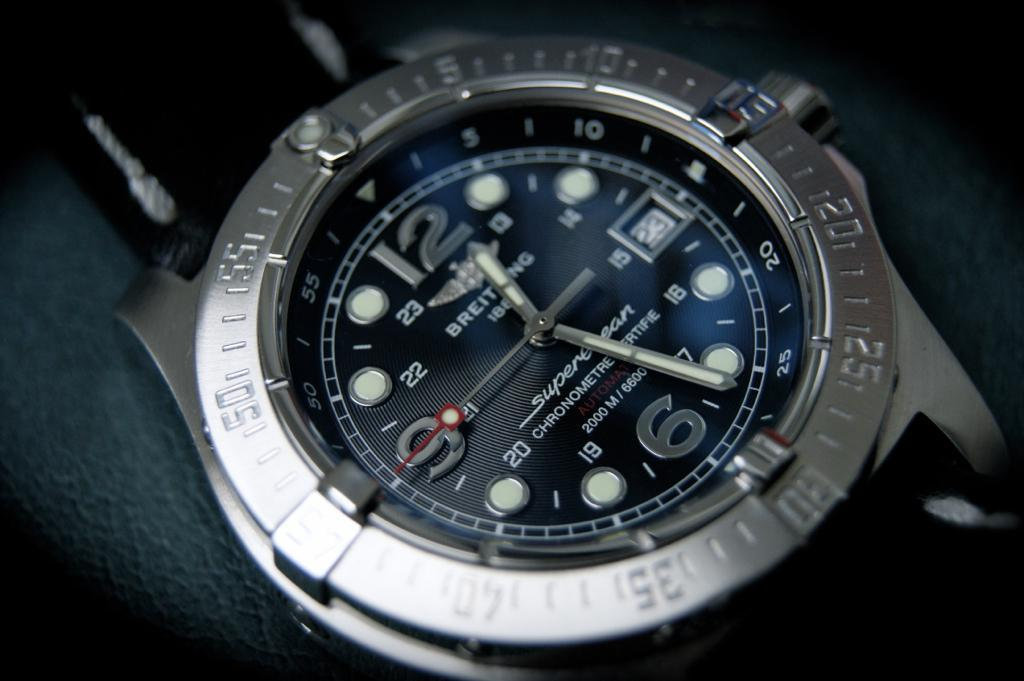<image>
Write a terse but informative summary of the picture. Watch that says 12:26 that is in a gray color, and the date is 23. 